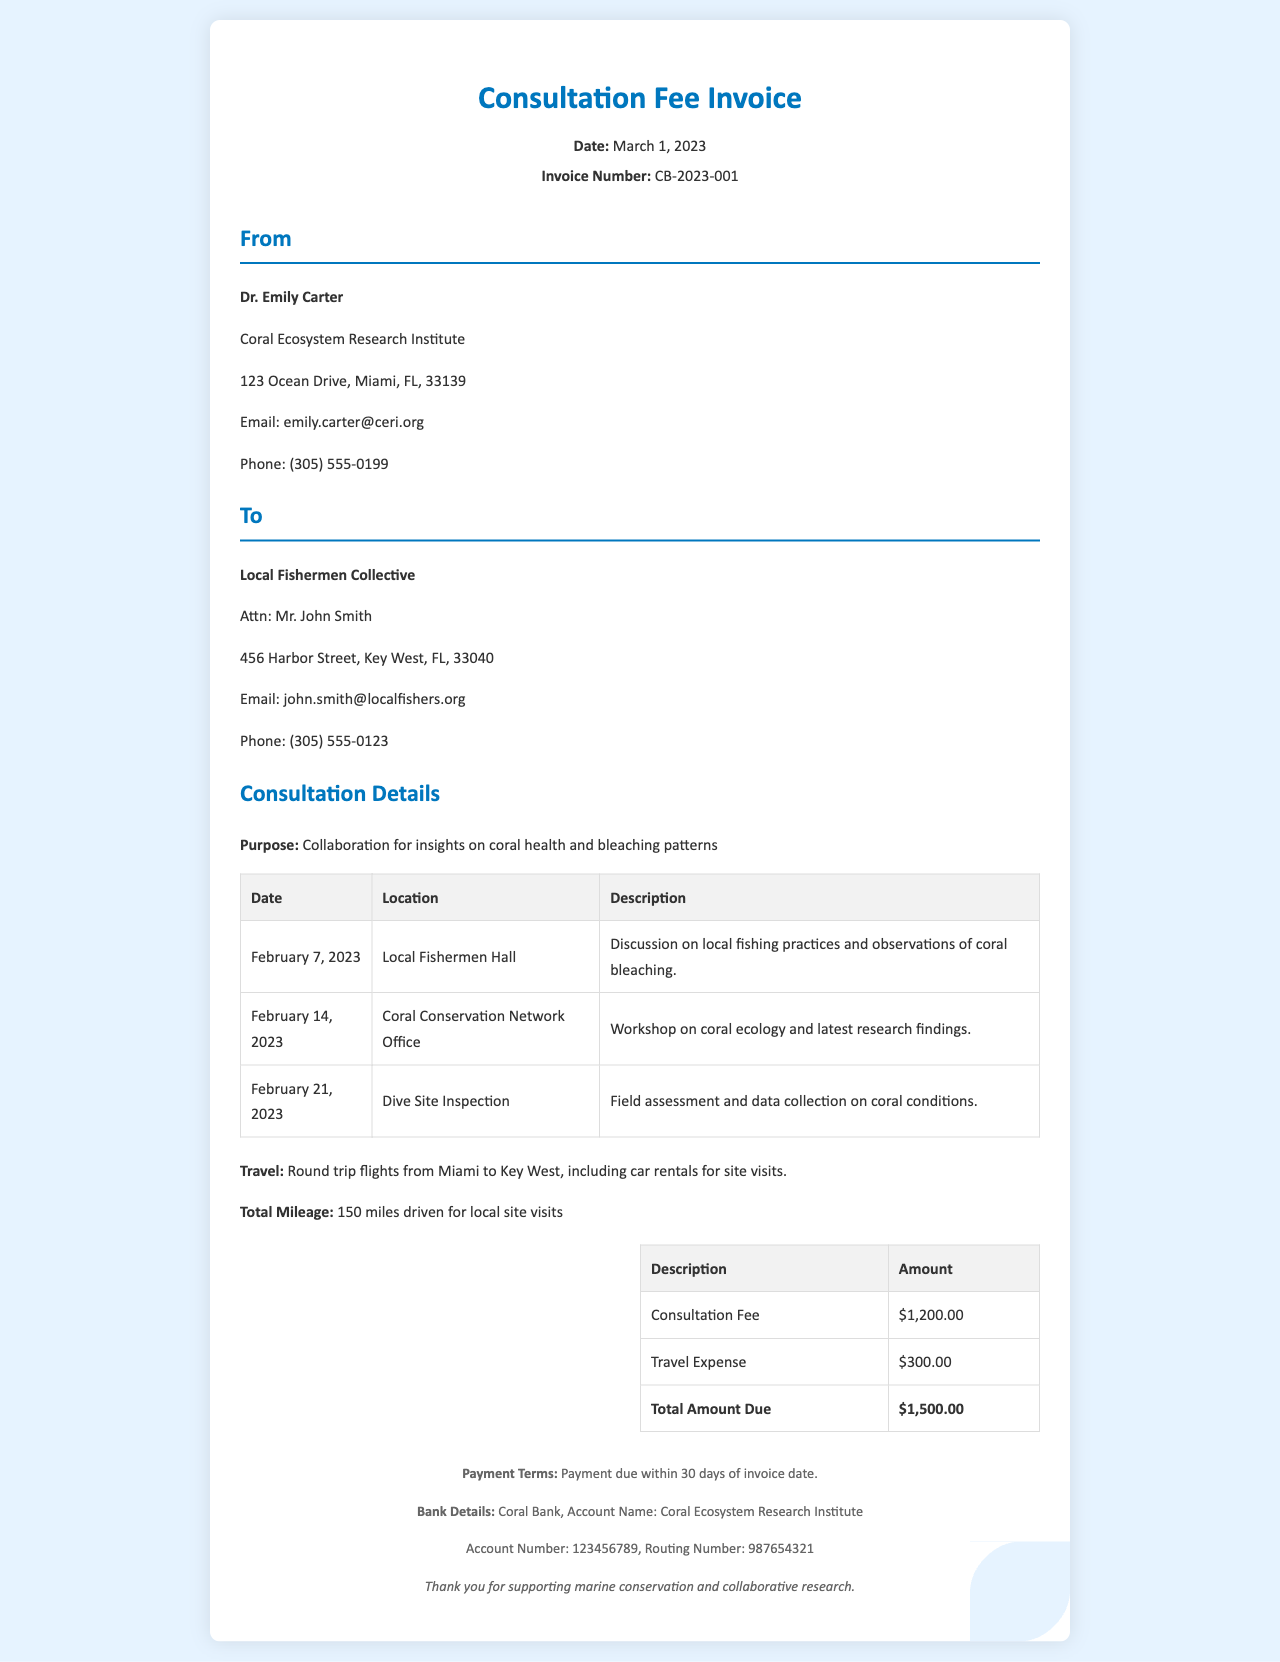What is the invoice number? The invoice number is listed in the header of the invoice as "CB-2023-001".
Answer: CB-2023-001 Who is the recipient of the invoice? The recipient of the invoice is noted in the recipient section, specifically as the "Local Fishermen Collective".
Answer: Local Fishermen Collective What is the total amount due? The total amount due is calculated and presented in the fees section of the document as "$1,500.00".
Answer: $1,500.00 How many meetings were documented in February? The document lists three meetings that took place in February 2023.
Answer: Three What is the purpose of the consultation? The purpose is explicitly stated in the consultation details section as "Collaboration for insights on coral health and bleaching patterns".
Answer: Collaboration for insights on coral health and bleaching patterns What is the date of the invoice? The date of the invoice is found in the header section, specifically as "March 1, 2023".
Answer: March 1, 2023 What is the travel expense amount? The travel expense is clearly listed in the fees section as "$300.00".
Answer: $300.00 What payment terms are specified in the invoice? The payment terms are listed towards the bottom of the invoice as "Payment due within 30 days of invoice date."
Answer: Payment due within 30 days of invoice date Where did the field assessment take place? The field assessment is mentioned to have taken place at "Dive Site Inspection".
Answer: Dive Site Inspection 